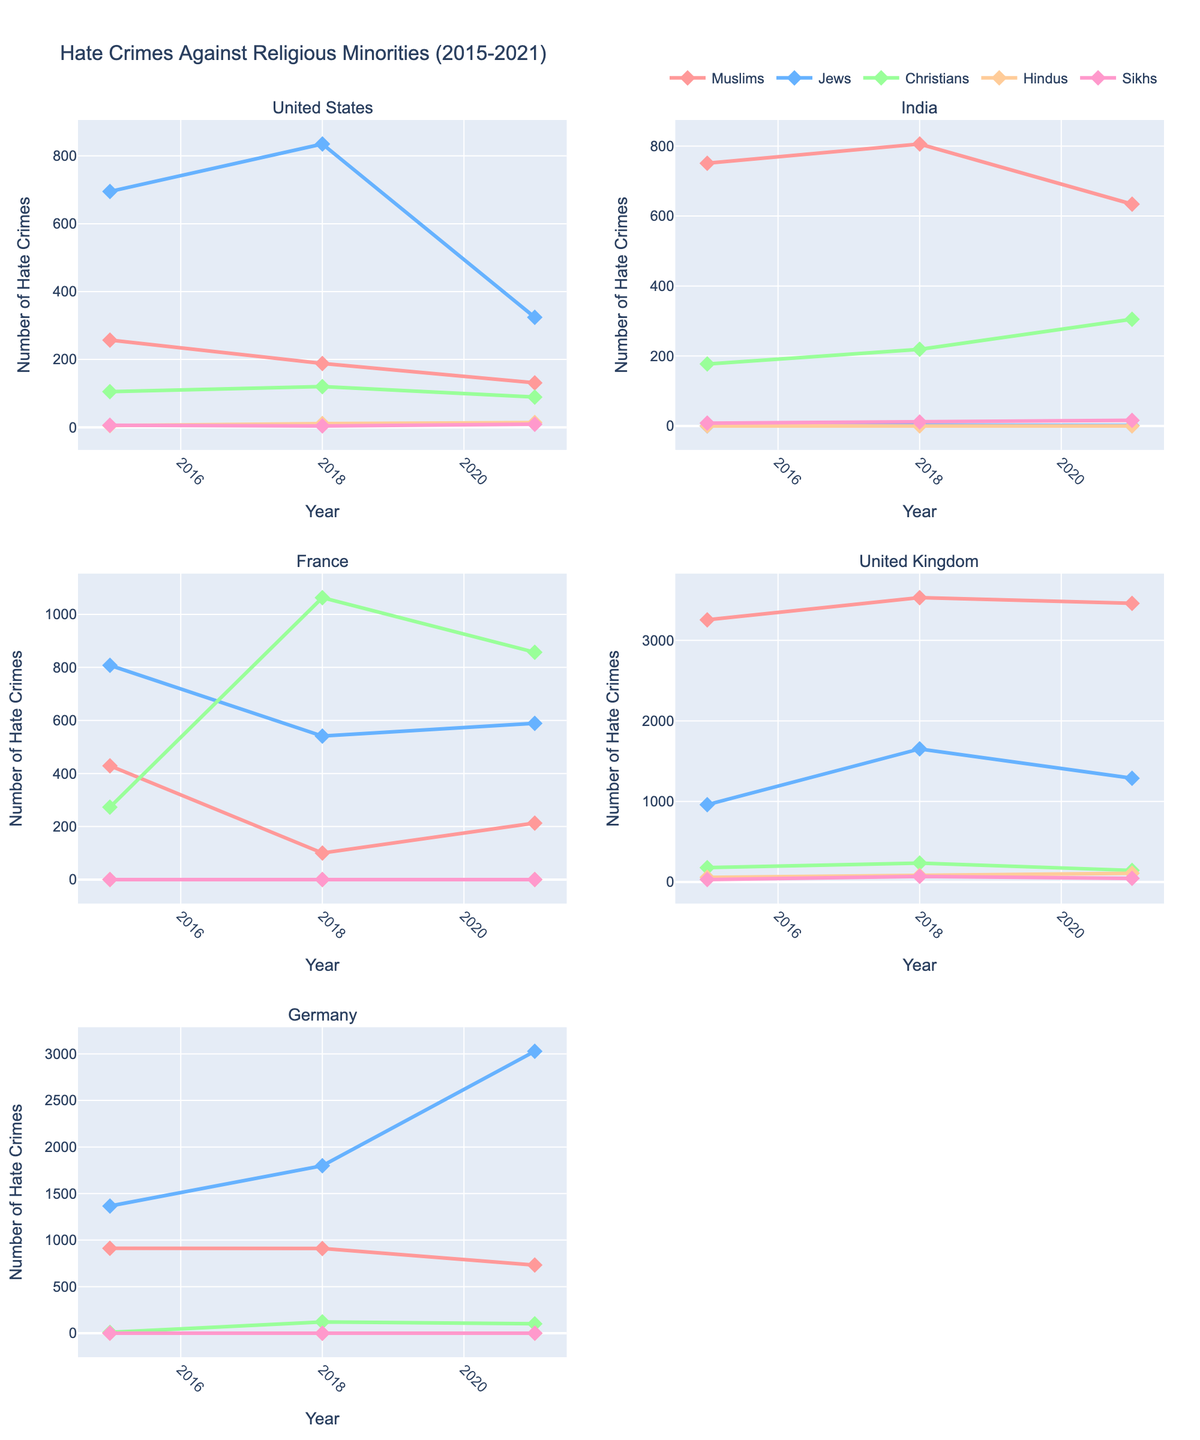What is the overall trend of hate crimes against Muslims in the United States from 2015 to 2021? To discern the trend, locate the United States subplot and observe the line for hate crimes against Muslims. The plotted points indicate a decline from 257 in 2015 to 131 in 2021.
Answer: Decreasing Which country showed an increase in hate crimes against Christians from 2015 to 2021? For this, look at the subplots for trends in hate crimes against Christians for each country from 2015 to 2021. Only India and France exhibit an increase over this period.
Answer: India and France How many hate crimes against Jews were reported in Germany in 2021? Refer to the subplot for Germany and identify the point representing hate crimes against Jews in 2021. The value is shown at 3028.
Answer: 3028 Which religion faced the most hate crimes in the United Kingdom in 2018? Examine the United Kingdom subplot and compare the heights of lines for each religion in 2018. The line for Muslims is the highest at 3530.
Answer: Muslims Did hate crimes against Hindus in the United Kingdom increase or decrease from 2015 to 2021? Look at the subplot for the United Kingdom and trace the line for hate crimes against Hindus from 2015 to 2021. The data shows an increase from 58 in 2015 to 108 in 2021.
Answer: Increase What is the general trend of hate crimes against Sikhs in India from 2015 to 2021? Locate the India subplot and follow the line representing hate crimes against Sikhs over the years. The trend shows an upward trajectory from 8 in 2015 to 16 in 2021.
Answer: Increasing Are hate crimes against Muslims higher in France or Germany in 2015? Compare the heights of lines representing hate crimes against Muslims in France and Germany in the 2015 subplots. France shows a lower number at 429 compared to Germany's 912.
Answer: Germany In which year did hate crimes against Christians peak in France? In the France subplot, follow the line for hate crimes against Christians. The peak appears in 2018 at the highest value of 1063.
Answer: 2018 How did hate crimes against Jews change in the United States from 2015 to 2021? Look at the United States subplot and track the line for hate crimes against Jews between 2015 and 2021. The graph shows a fluctuating pattern, first increasing from 2015 to 2018, then sharply decreasing by 2021.
Answer: Increased then decreased Which country had the highest number of hate crimes against Muslims in 2021? Observe the subplots and compare the hate crimes against Muslims in 2021 across all countries. The United Kingdom has the highest value at 3459.
Answer: United Kingdom 